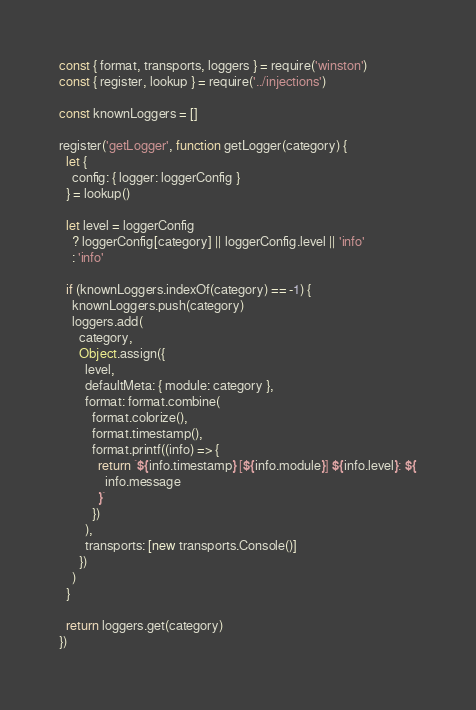<code> <loc_0><loc_0><loc_500><loc_500><_JavaScript_>const { format, transports, loggers } = require('winston')
const { register, lookup } = require('../injections')

const knownLoggers = []

register('getLogger', function getLogger(category) {
  let {
    config: { logger: loggerConfig }
  } = lookup()

  let level = loggerConfig
    ? loggerConfig[category] || loggerConfig.level || 'info'
    : 'info'

  if (knownLoggers.indexOf(category) == -1) {
    knownLoggers.push(category)
    loggers.add(
      category,
      Object.assign({
        level,
        defaultMeta: { module: category },
        format: format.combine(
          format.colorize(),
          format.timestamp(),
          format.printf((info) => {
            return `${info.timestamp} [${info.module}] ${info.level}: ${
              info.message
            }`
          })
        ),
        transports: [new transports.Console()]
      })
    )
  }

  return loggers.get(category)
})
</code> 